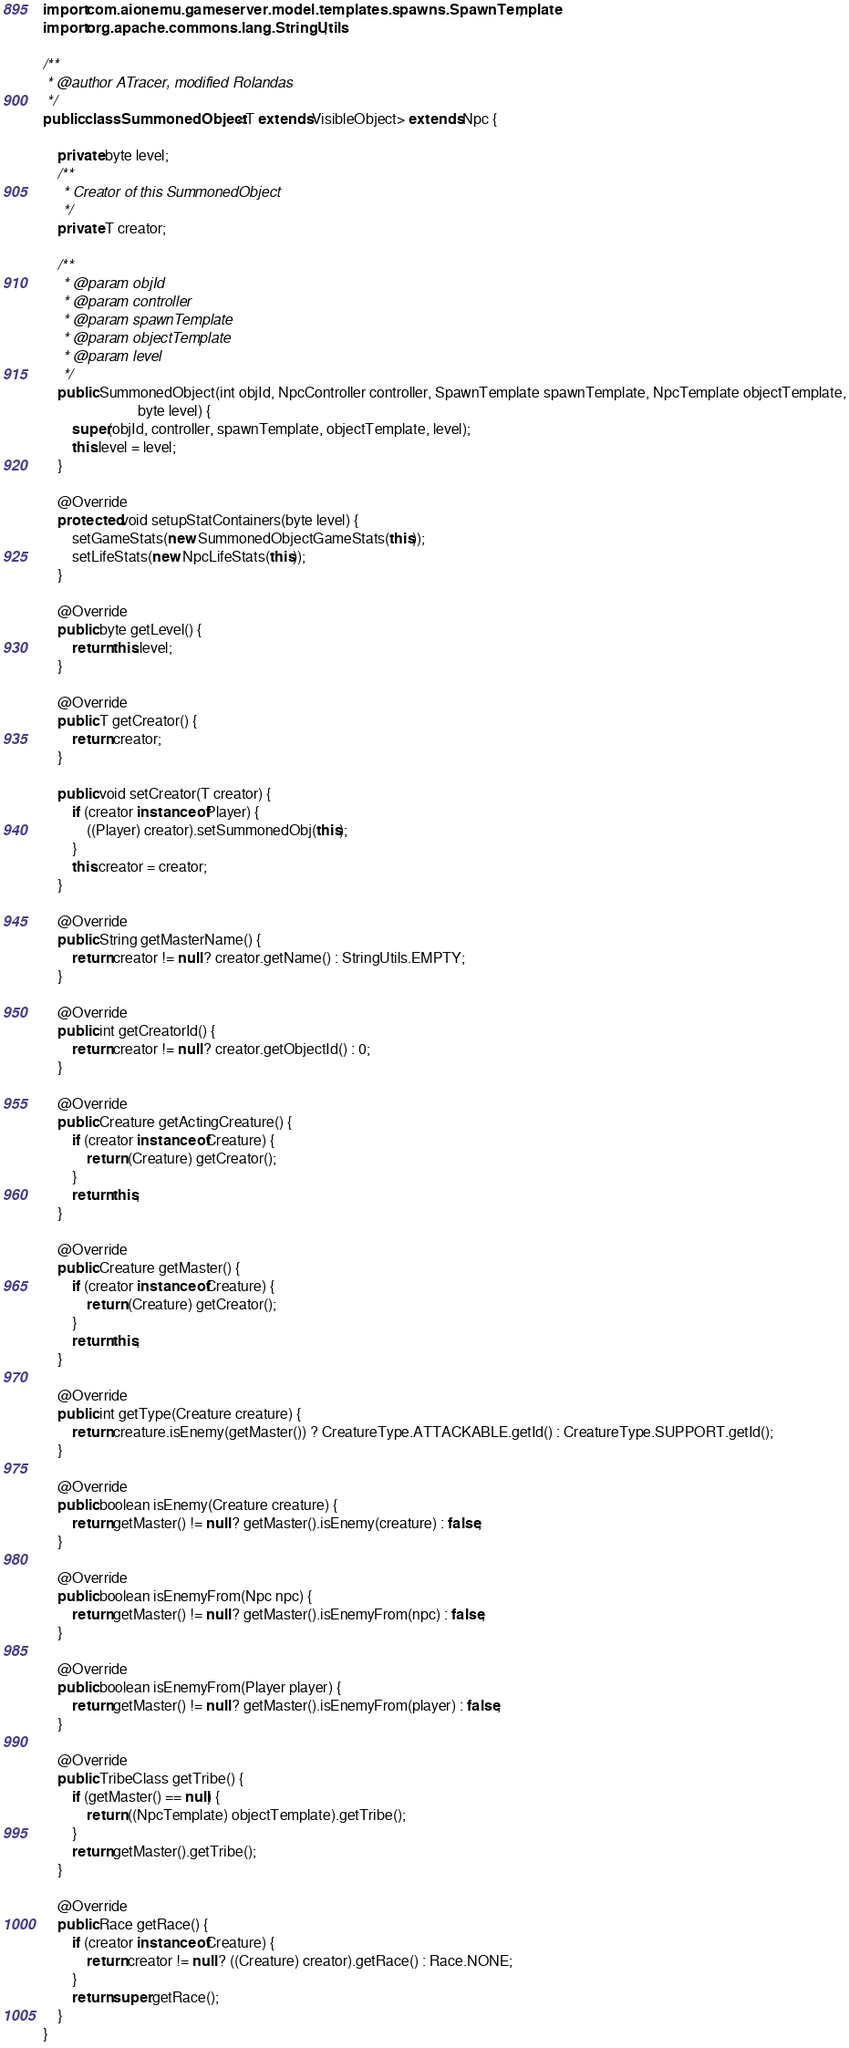<code> <loc_0><loc_0><loc_500><loc_500><_Java_>import com.aionemu.gameserver.model.templates.spawns.SpawnTemplate;
import org.apache.commons.lang.StringUtils;

/**
 * @author ATracer, modified Rolandas
 */
public class SummonedObject<T extends VisibleObject> extends Npc {

    private byte level;
    /**
     * Creator of this SummonedObject
     */
    private T creator;

    /**
     * @param objId
     * @param controller
     * @param spawnTemplate
     * @param objectTemplate
     * @param level
     */
    public SummonedObject(int objId, NpcController controller, SpawnTemplate spawnTemplate, NpcTemplate objectTemplate,
                          byte level) {
        super(objId, controller, spawnTemplate, objectTemplate, level);
        this.level = level;
    }

    @Override
    protected void setupStatContainers(byte level) {
        setGameStats(new SummonedObjectGameStats(this));
        setLifeStats(new NpcLifeStats(this));
    }

    @Override
    public byte getLevel() {
        return this.level;
    }

    @Override
    public T getCreator() {
        return creator;
    }

    public void setCreator(T creator) {
        if (creator instanceof Player) {
            ((Player) creator).setSummonedObj(this);
        }
        this.creator = creator;
    }

    @Override
    public String getMasterName() {
        return creator != null ? creator.getName() : StringUtils.EMPTY;
    }

    @Override
    public int getCreatorId() {
        return creator != null ? creator.getObjectId() : 0;
    }

    @Override
    public Creature getActingCreature() {
        if (creator instanceof Creature) {
            return (Creature) getCreator();
        }
        return this;
    }

    @Override
    public Creature getMaster() {
        if (creator instanceof Creature) {
            return (Creature) getCreator();
        }
        return this;
    }

    @Override
    public int getType(Creature creature) {
        return creature.isEnemy(getMaster()) ? CreatureType.ATTACKABLE.getId() : CreatureType.SUPPORT.getId();
    }

    @Override
    public boolean isEnemy(Creature creature) {
        return getMaster() != null ? getMaster().isEnemy(creature) : false;
    }

    @Override
    public boolean isEnemyFrom(Npc npc) {
        return getMaster() != null ? getMaster().isEnemyFrom(npc) : false;
    }

    @Override
    public boolean isEnemyFrom(Player player) {
        return getMaster() != null ? getMaster().isEnemyFrom(player) : false;
    }

    @Override
    public TribeClass getTribe() {
        if (getMaster() == null) {
            return ((NpcTemplate) objectTemplate).getTribe();
        }
        return getMaster().getTribe();
    }

    @Override
    public Race getRace() {
        if (creator instanceof Creature) {
            return creator != null ? ((Creature) creator).getRace() : Race.NONE;
        }
        return super.getRace();
    }
}
</code> 